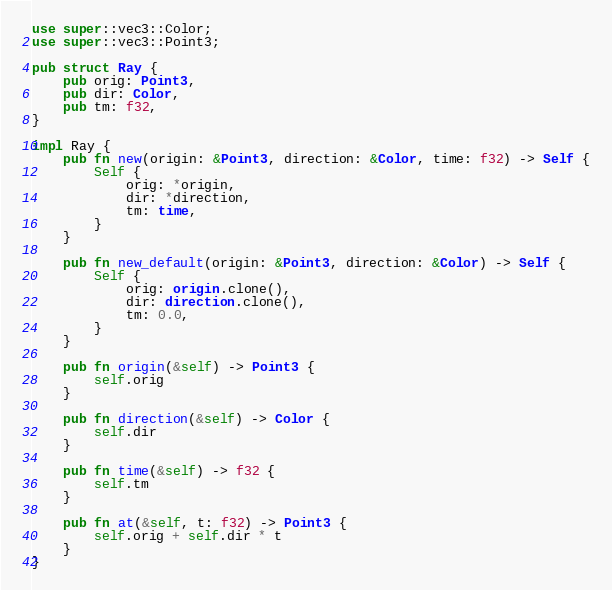Convert code to text. <code><loc_0><loc_0><loc_500><loc_500><_Rust_>use super::vec3::Color;
use super::vec3::Point3;

pub struct Ray {
    pub orig: Point3,
    pub dir: Color,
    pub tm: f32,
}

impl Ray {
    pub fn new(origin: &Point3, direction: &Color, time: f32) -> Self {
        Self {
            orig: *origin,
            dir: *direction,
            tm: time,
        }
    }

    pub fn new_default(origin: &Point3, direction: &Color) -> Self {
        Self {
            orig: origin.clone(),
            dir: direction.clone(),
            tm: 0.0,
        }
    }

    pub fn origin(&self) -> Point3 {
        self.orig
    }

    pub fn direction(&self) -> Color {
        self.dir
    }

    pub fn time(&self) -> f32 {
        self.tm
    }

    pub fn at(&self, t: f32) -> Point3 {
        self.orig + self.dir * t
    }
}
</code> 